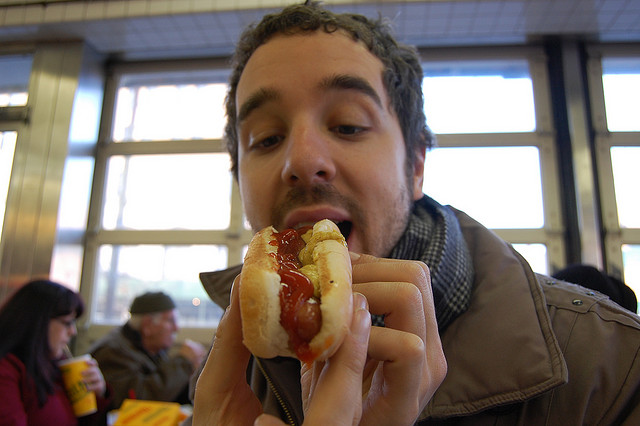Can you describe the setting around the person? Sure! The person appears to be inside a casual dining space, likely a diner or fast food restaurant, given the simple interior decor and the presence of other patrons in the background. 